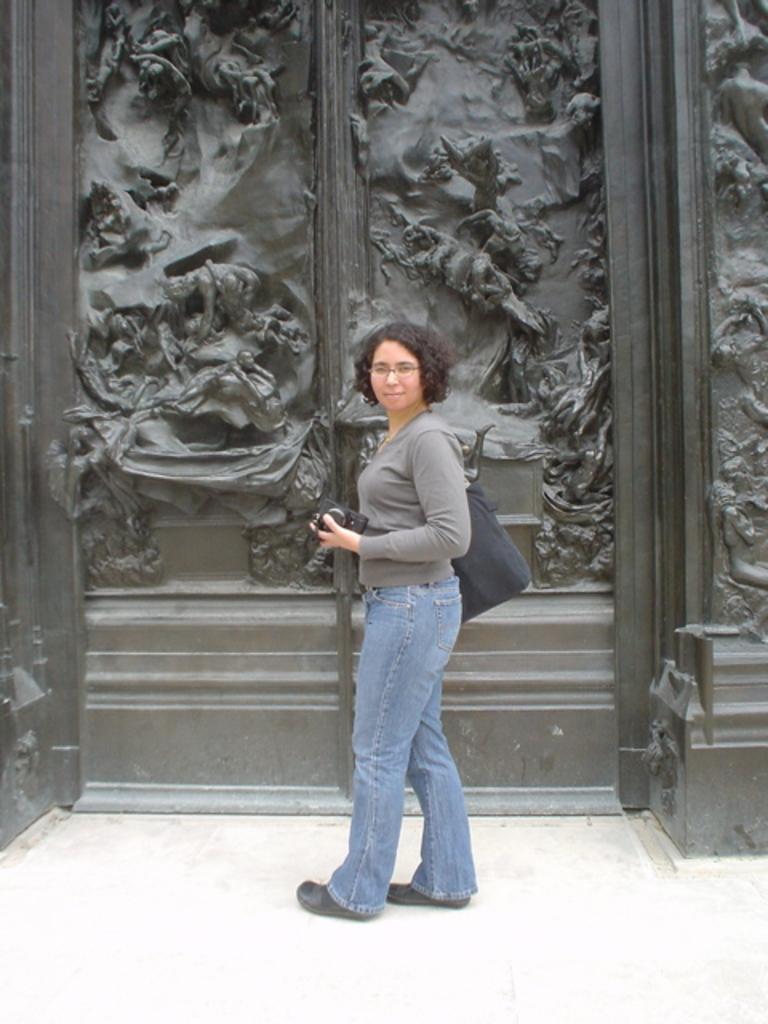Describe this image in one or two sentences. In this picture there is a woman who is wearing spectacle t-shirt, bag, jeans and shoe. She is holding a camera. She is standing near to the door. On the right there is a wall. At the bottom there is a floor. 